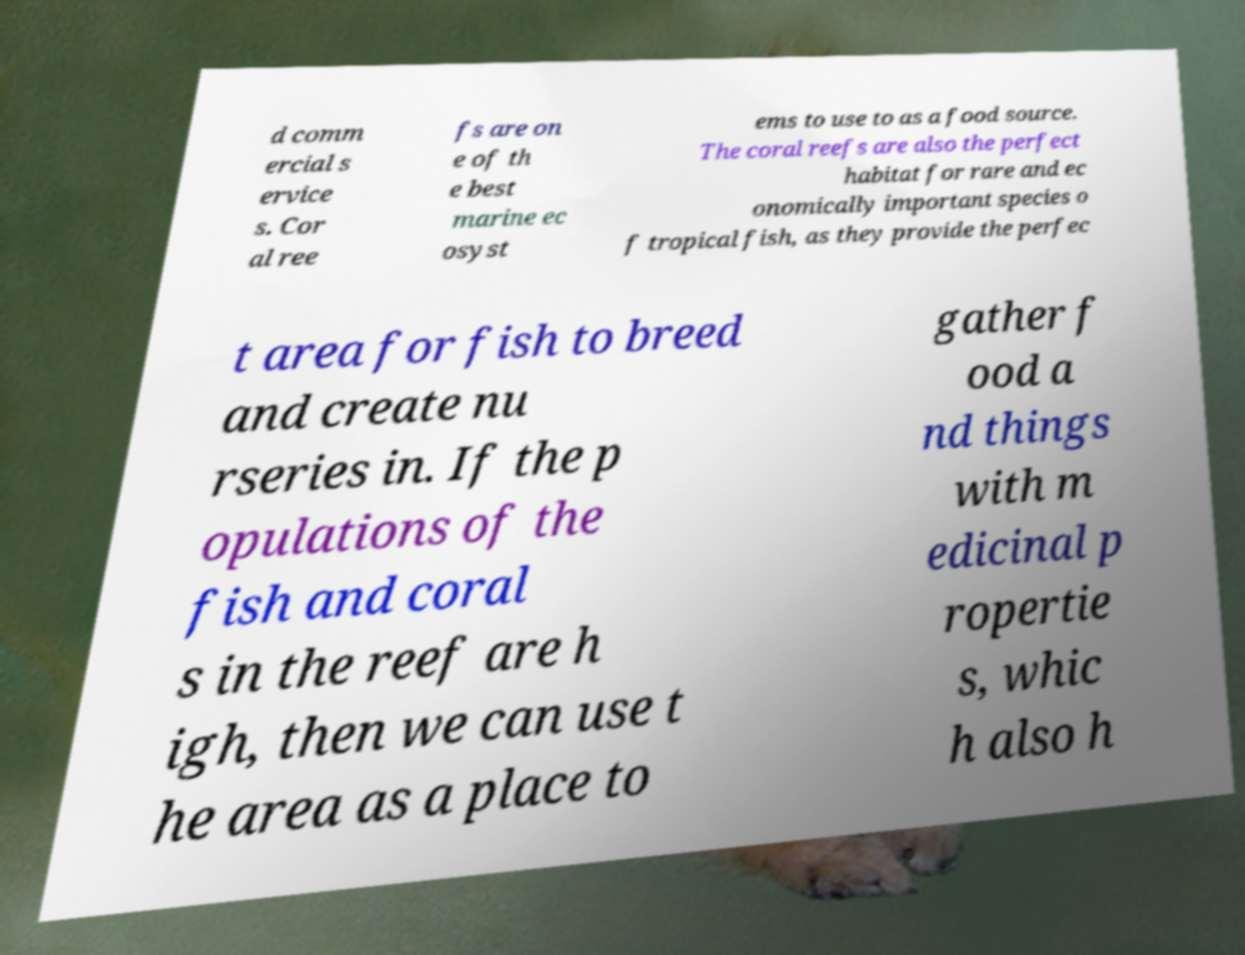Could you assist in decoding the text presented in this image and type it out clearly? d comm ercial s ervice s. Cor al ree fs are on e of th e best marine ec osyst ems to use to as a food source. The coral reefs are also the perfect habitat for rare and ec onomically important species o f tropical fish, as they provide the perfec t area for fish to breed and create nu rseries in. If the p opulations of the fish and coral s in the reef are h igh, then we can use t he area as a place to gather f ood a nd things with m edicinal p ropertie s, whic h also h 